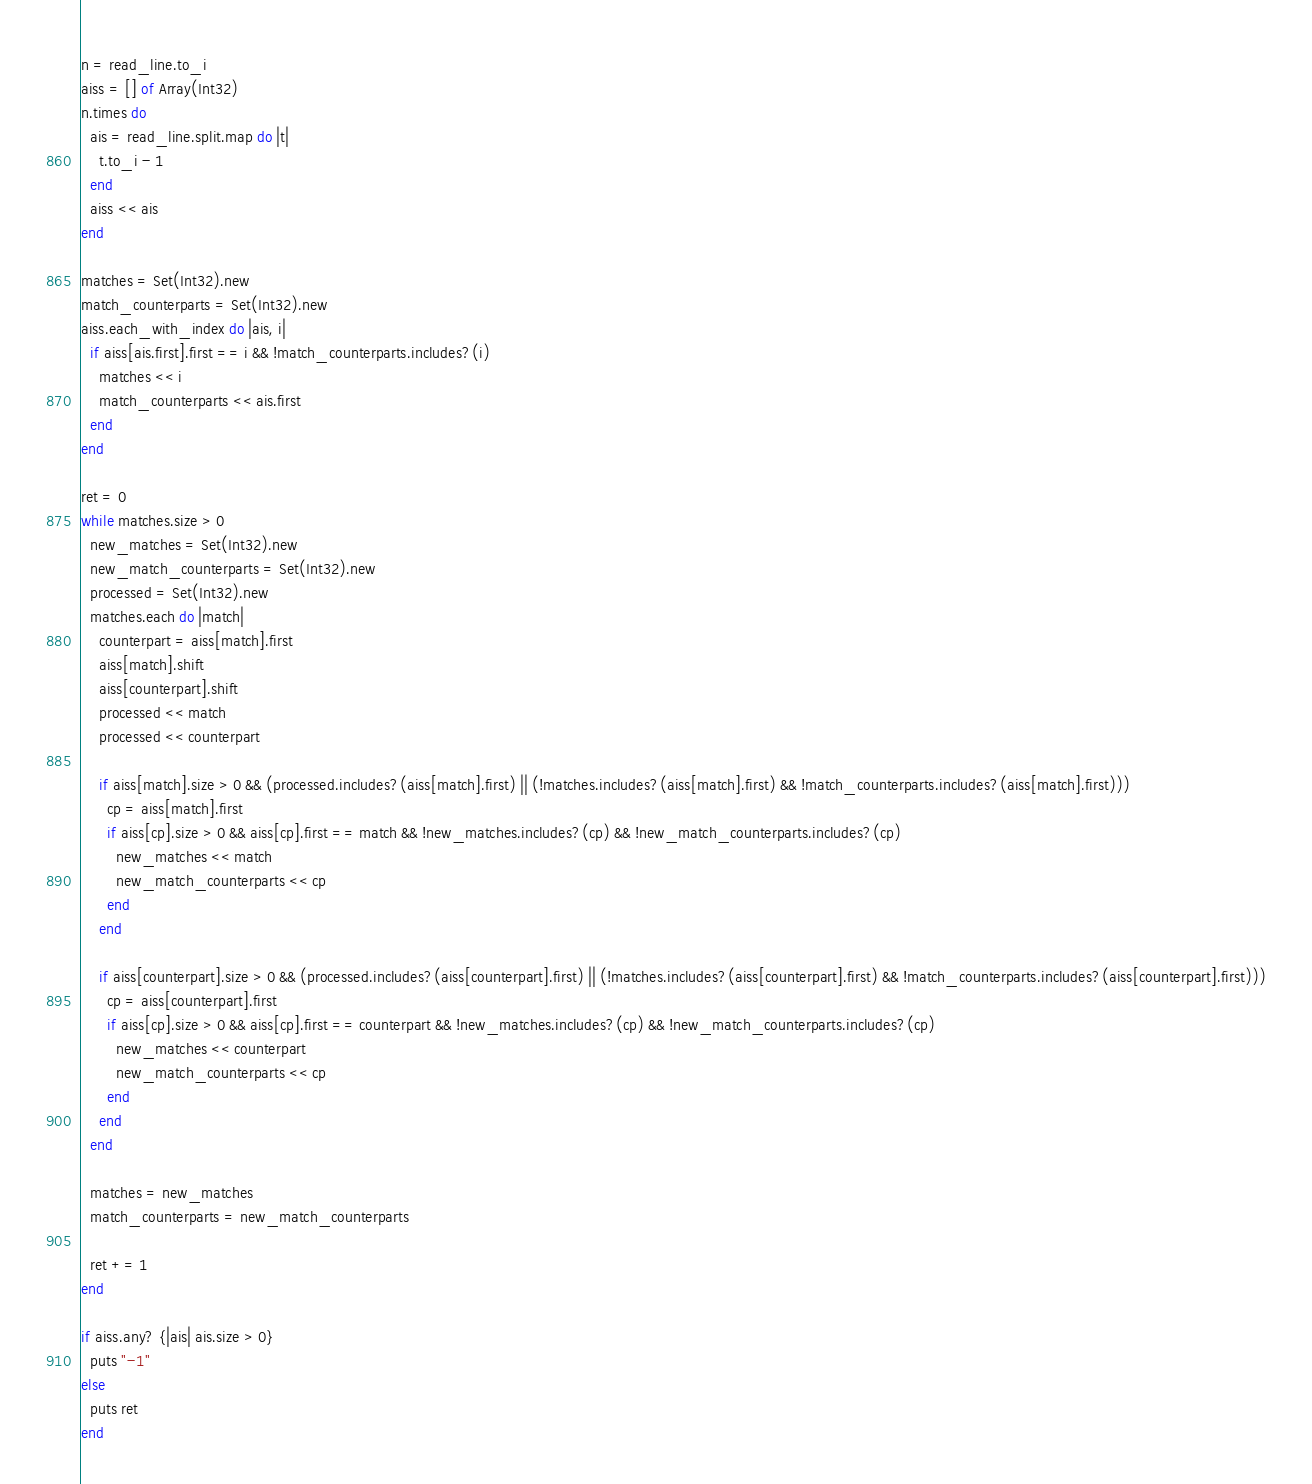<code> <loc_0><loc_0><loc_500><loc_500><_Crystal_>n = read_line.to_i
aiss = [] of Array(Int32)
n.times do
  ais = read_line.split.map do |t|
    t.to_i - 1
  end
  aiss << ais
end

matches = Set(Int32).new
match_counterparts = Set(Int32).new
aiss.each_with_index do |ais, i|
  if aiss[ais.first].first == i && !match_counterparts.includes?(i)
    matches << i
    match_counterparts << ais.first
  end
end

ret = 0
while matches.size > 0
  new_matches = Set(Int32).new
  new_match_counterparts = Set(Int32).new
  processed = Set(Int32).new
  matches.each do |match|
    counterpart = aiss[match].first
    aiss[match].shift
    aiss[counterpart].shift
    processed << match
    processed << counterpart

    if aiss[match].size > 0 && (processed.includes?(aiss[match].first) || (!matches.includes?(aiss[match].first) && !match_counterparts.includes?(aiss[match].first)))
      cp = aiss[match].first
      if aiss[cp].size > 0 && aiss[cp].first == match && !new_matches.includes?(cp) && !new_match_counterparts.includes?(cp)
        new_matches << match
        new_match_counterparts << cp
      end
    end

    if aiss[counterpart].size > 0 && (processed.includes?(aiss[counterpart].first) || (!matches.includes?(aiss[counterpart].first) && !match_counterparts.includes?(aiss[counterpart].first)))
      cp = aiss[counterpart].first
      if aiss[cp].size > 0 && aiss[cp].first == counterpart && !new_matches.includes?(cp) && !new_match_counterparts.includes?(cp)
        new_matches << counterpart
        new_match_counterparts << cp
      end
    end
  end

  matches = new_matches
  match_counterparts = new_match_counterparts

  ret += 1
end

if aiss.any? {|ais| ais.size > 0}
  puts "-1"
else
  puts ret
end</code> 